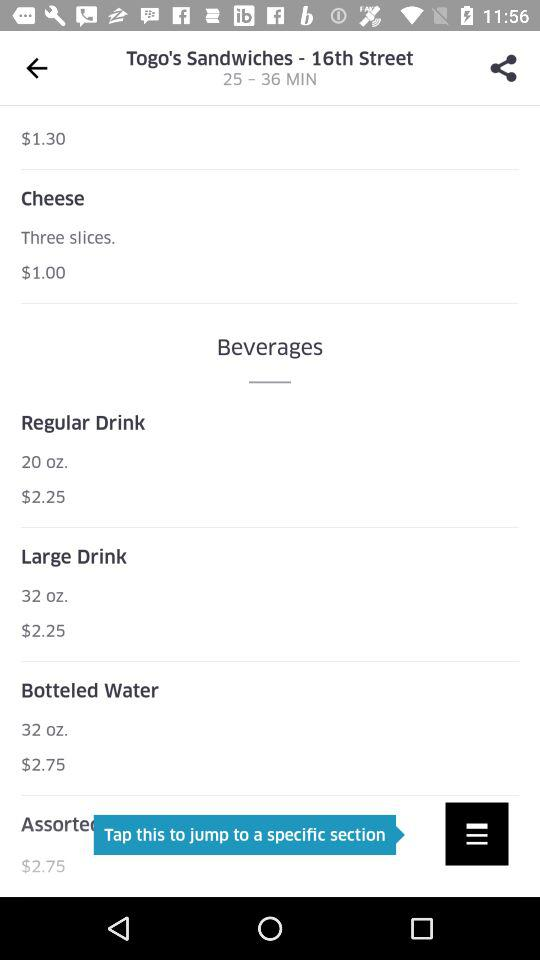How many "Cheese" slices are there? There are three "Cheese" slices. 